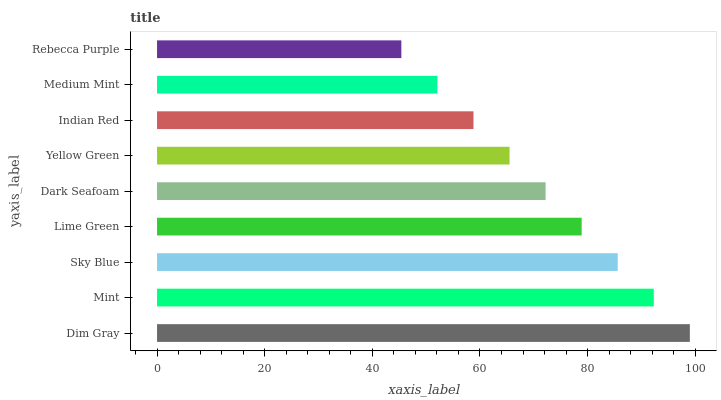Is Rebecca Purple the minimum?
Answer yes or no. Yes. Is Dim Gray the maximum?
Answer yes or no. Yes. Is Mint the minimum?
Answer yes or no. No. Is Mint the maximum?
Answer yes or no. No. Is Dim Gray greater than Mint?
Answer yes or no. Yes. Is Mint less than Dim Gray?
Answer yes or no. Yes. Is Mint greater than Dim Gray?
Answer yes or no. No. Is Dim Gray less than Mint?
Answer yes or no. No. Is Dark Seafoam the high median?
Answer yes or no. Yes. Is Dark Seafoam the low median?
Answer yes or no. Yes. Is Sky Blue the high median?
Answer yes or no. No. Is Dim Gray the low median?
Answer yes or no. No. 